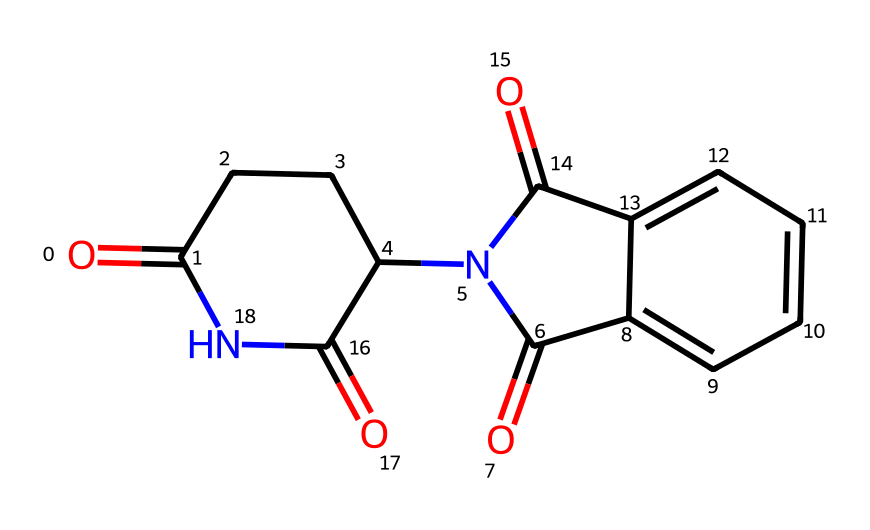What is the IUPAC name of the compound represented by this SMILES? The SMILES notation provided corresponds to the structure of thalidomide, which is a well-known chiral drug. By analyzing the components in the SMILES, it can be deduced that the full IUPAC name is N-(o-carboxyphenyl)-α-(N'-phthalimido) propionic acid.
Answer: N-(o-carboxyphenyl)-α-(N'-phthalimido) propionic acid How many chiral centers are present in thalidomide? To determine the number of chiral centers in thalidomide, we must look for carbon atoms bonded to four different substituents. In the provided chemical structure, there is one such carbon. Therefore, thalidomide has one chiral center.
Answer: one What is the total number of nitrogen atoms in the structure? By examining the chemical structure, we can count the nitrogen atoms (N). In the given SMILES representation, there are two nitrogen atoms present in thalidomide.
Answer: two What type of functional groups are present in thalidomide? The compound contains several functional groups, including an amide group (from the nitrogen atoms and their bonding), a carbonyl group (C=O), and a familial aromatic ring (indicating the presence of phenolic compounds). These components allow us to identify it as containing amide and carbonyl groups prominently.
Answer: amide, carbonyl What significant historical issue is associated with thalidomide? Thalidomide is infamously known for its association with birth defects when prescribed to pregnant women in the late 1950s and early 1960s. Due to its chiral nature, one enantiomer provided the desired sedative effects, while the other caused severe teratogenic effects.
Answer: birth defects 